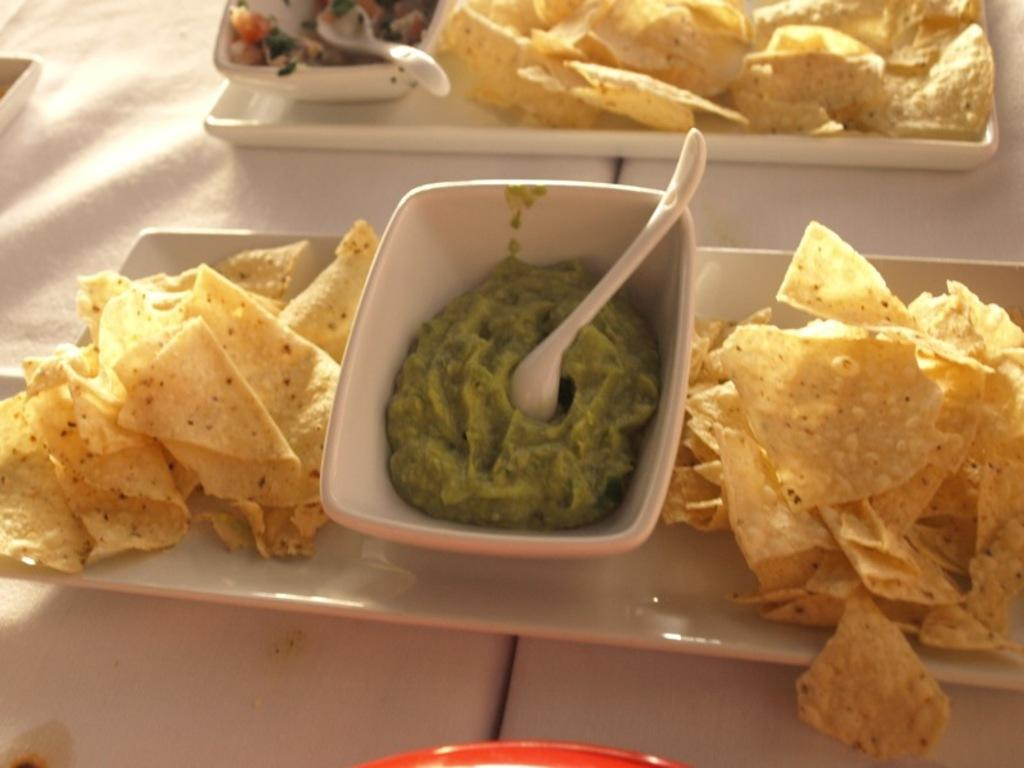What is the main piece of furniture in the image? There is a table in the image. What is placed on the table? There are bowls and trays on the table. What is inside the bowls? There are food items in the bowls. What is used to eat the food in the bowls? There are spoons on the bowls. What is on the trays? There are food items on the trays. What can be seen as decoration or part of the tablecloth? There are trees visible on the table. How does the digestion process of the geese in the image work? There are no geese present in the image, so it is not possible to discuss their digestion process. 